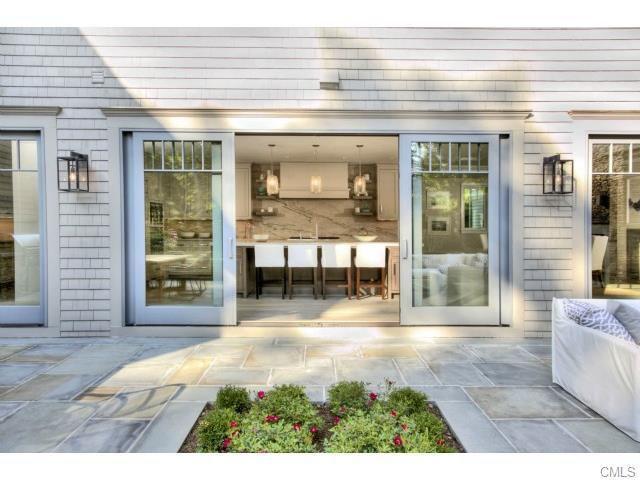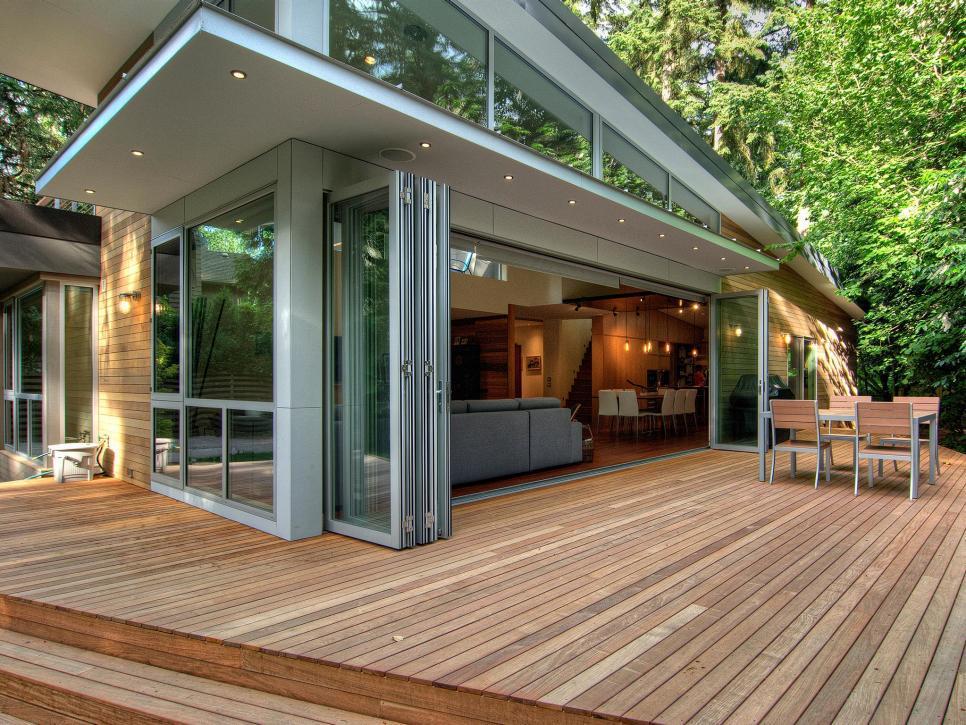The first image is the image on the left, the second image is the image on the right. Assess this claim about the two images: "In at least image there are six chairs surrounding a square table on the patio.". Correct or not? Answer yes or no. No. The first image is the image on the left, the second image is the image on the right. Considering the images on both sides, is "The right image is an exterior view of a wall of sliding glass doors, with stone-type surface in front, that face the camera and reveal a spacious furnished interior." valid? Answer yes or no. No. 